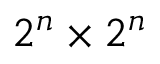<formula> <loc_0><loc_0><loc_500><loc_500>2 ^ { n } \times 2 ^ { n }</formula> 